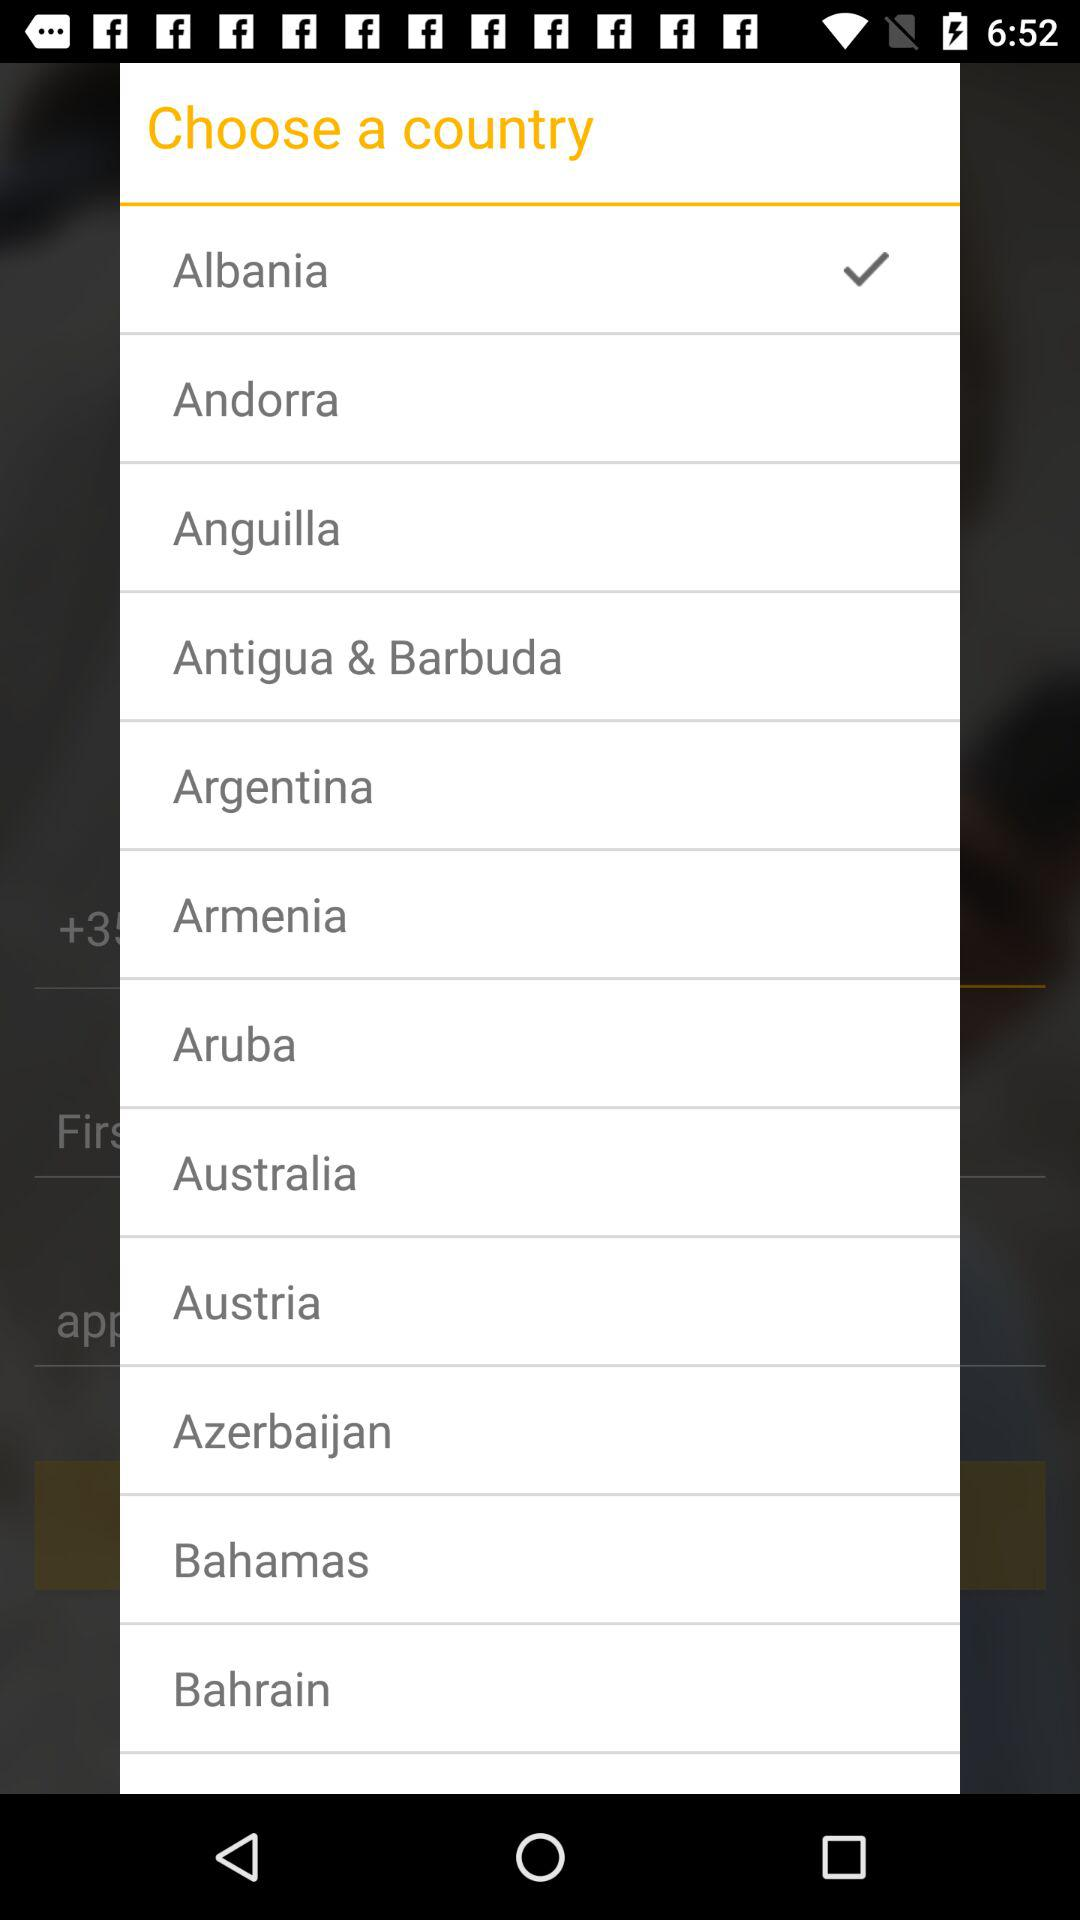Which country has been chosen? The chosen country is Albania. 